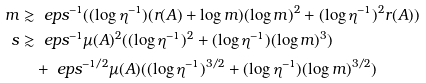Convert formula to latex. <formula><loc_0><loc_0><loc_500><loc_500>m & \gtrsim \ e p s ^ { - 1 } ( ( \log \eta ^ { - 1 } ) ( r ( A ) + \log m ) ( \log m ) ^ { 2 } + ( \log \eta ^ { - 1 } ) ^ { 2 } r ( A ) ) \\ s & \gtrsim \ e p s ^ { - 1 } \mu ( A ) ^ { 2 } ( ( \log \eta ^ { - 1 } ) ^ { 2 } + ( \log \eta ^ { - 1 } ) ( \log m ) ^ { 3 } ) \\ & \quad + \ e p s ^ { - 1 / 2 } \mu ( A ) ( ( \log \eta ^ { - 1 } ) ^ { 3 / 2 } + ( \log \eta ^ { - 1 } ) ( \log m ) ^ { 3 / 2 } )</formula> 